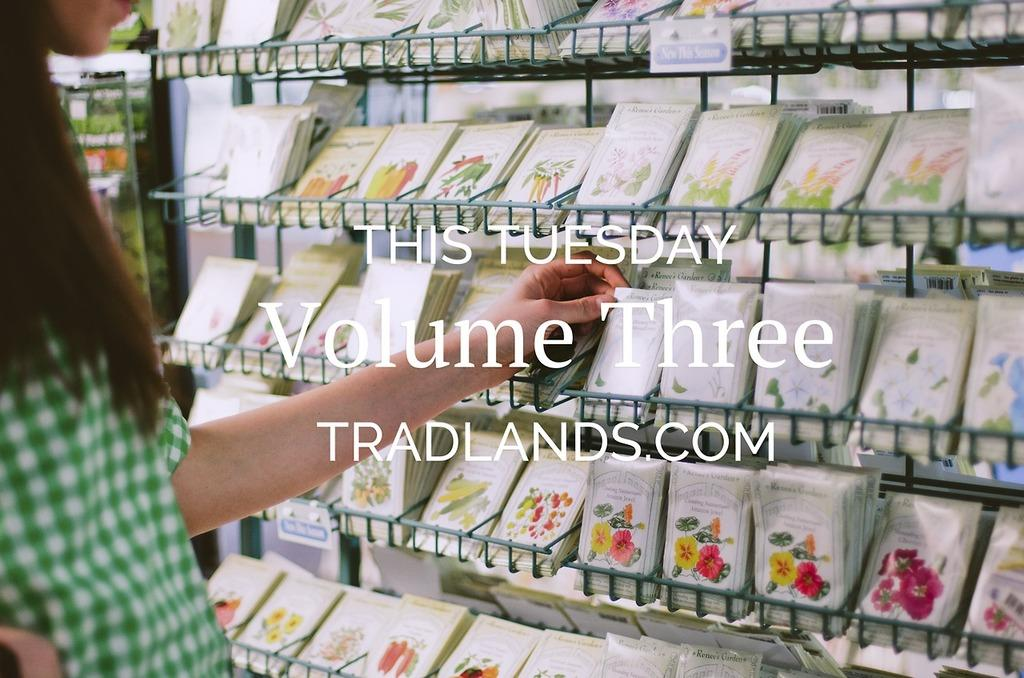<image>
Create a compact narrative representing the image presented. Tradlands.com advertises Volume Three this Tuesday in front of packets of seeds. 